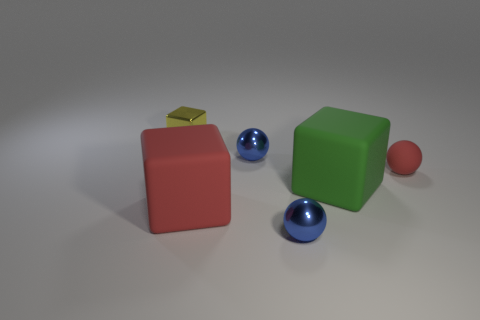There is a ball that is made of the same material as the large green object; what is its color?
Offer a very short reply. Red. Are there an equal number of small metallic spheres in front of the big green matte thing and small balls?
Give a very brief answer. No. There is a red thing to the left of the green rubber block; is its size the same as the big green matte object?
Provide a succinct answer. Yes. There is a block that is the same size as the matte ball; what color is it?
Your answer should be compact. Yellow. Are there any tiny red matte things on the left side of the blue sphere behind the red matte cube that is in front of the green rubber block?
Your answer should be very brief. No. There is a tiny blue thing behind the tiny rubber object; what is it made of?
Your response must be concise. Metal. Does the large green thing have the same shape as the small metal object in front of the big green matte cube?
Offer a terse response. No. Are there an equal number of red matte blocks in front of the yellow thing and red matte balls to the right of the big green thing?
Offer a very short reply. Yes. How many other objects are there of the same material as the yellow object?
Ensure brevity in your answer.  2. How many rubber things are large red cubes or big green blocks?
Ensure brevity in your answer.  2. 